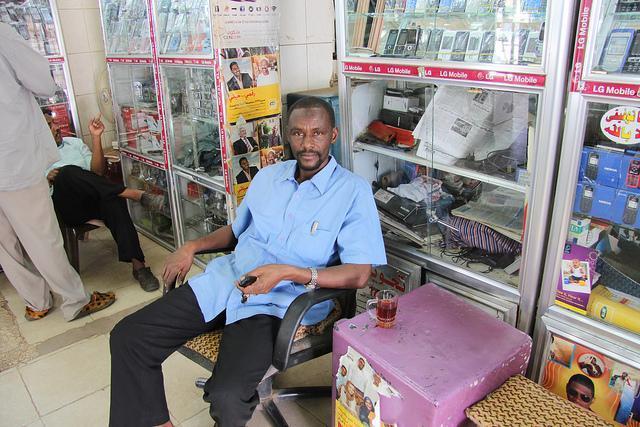How many people are visible?
Give a very brief answer. 3. How many zebras are there?
Give a very brief answer. 0. 